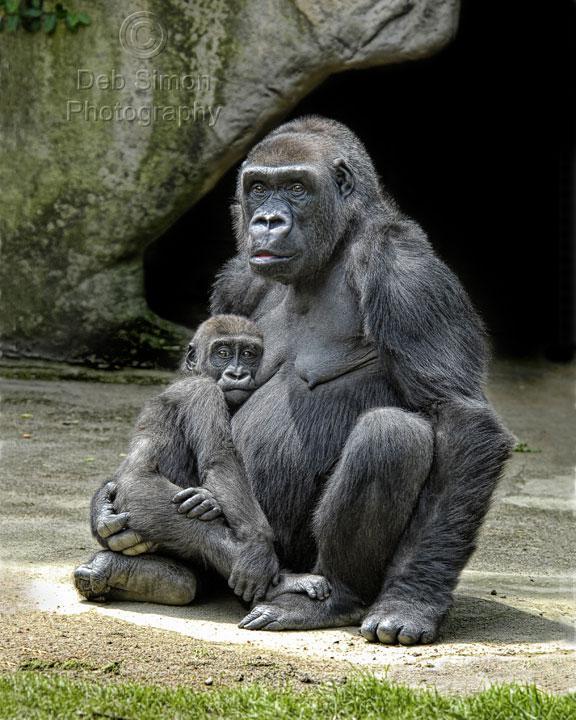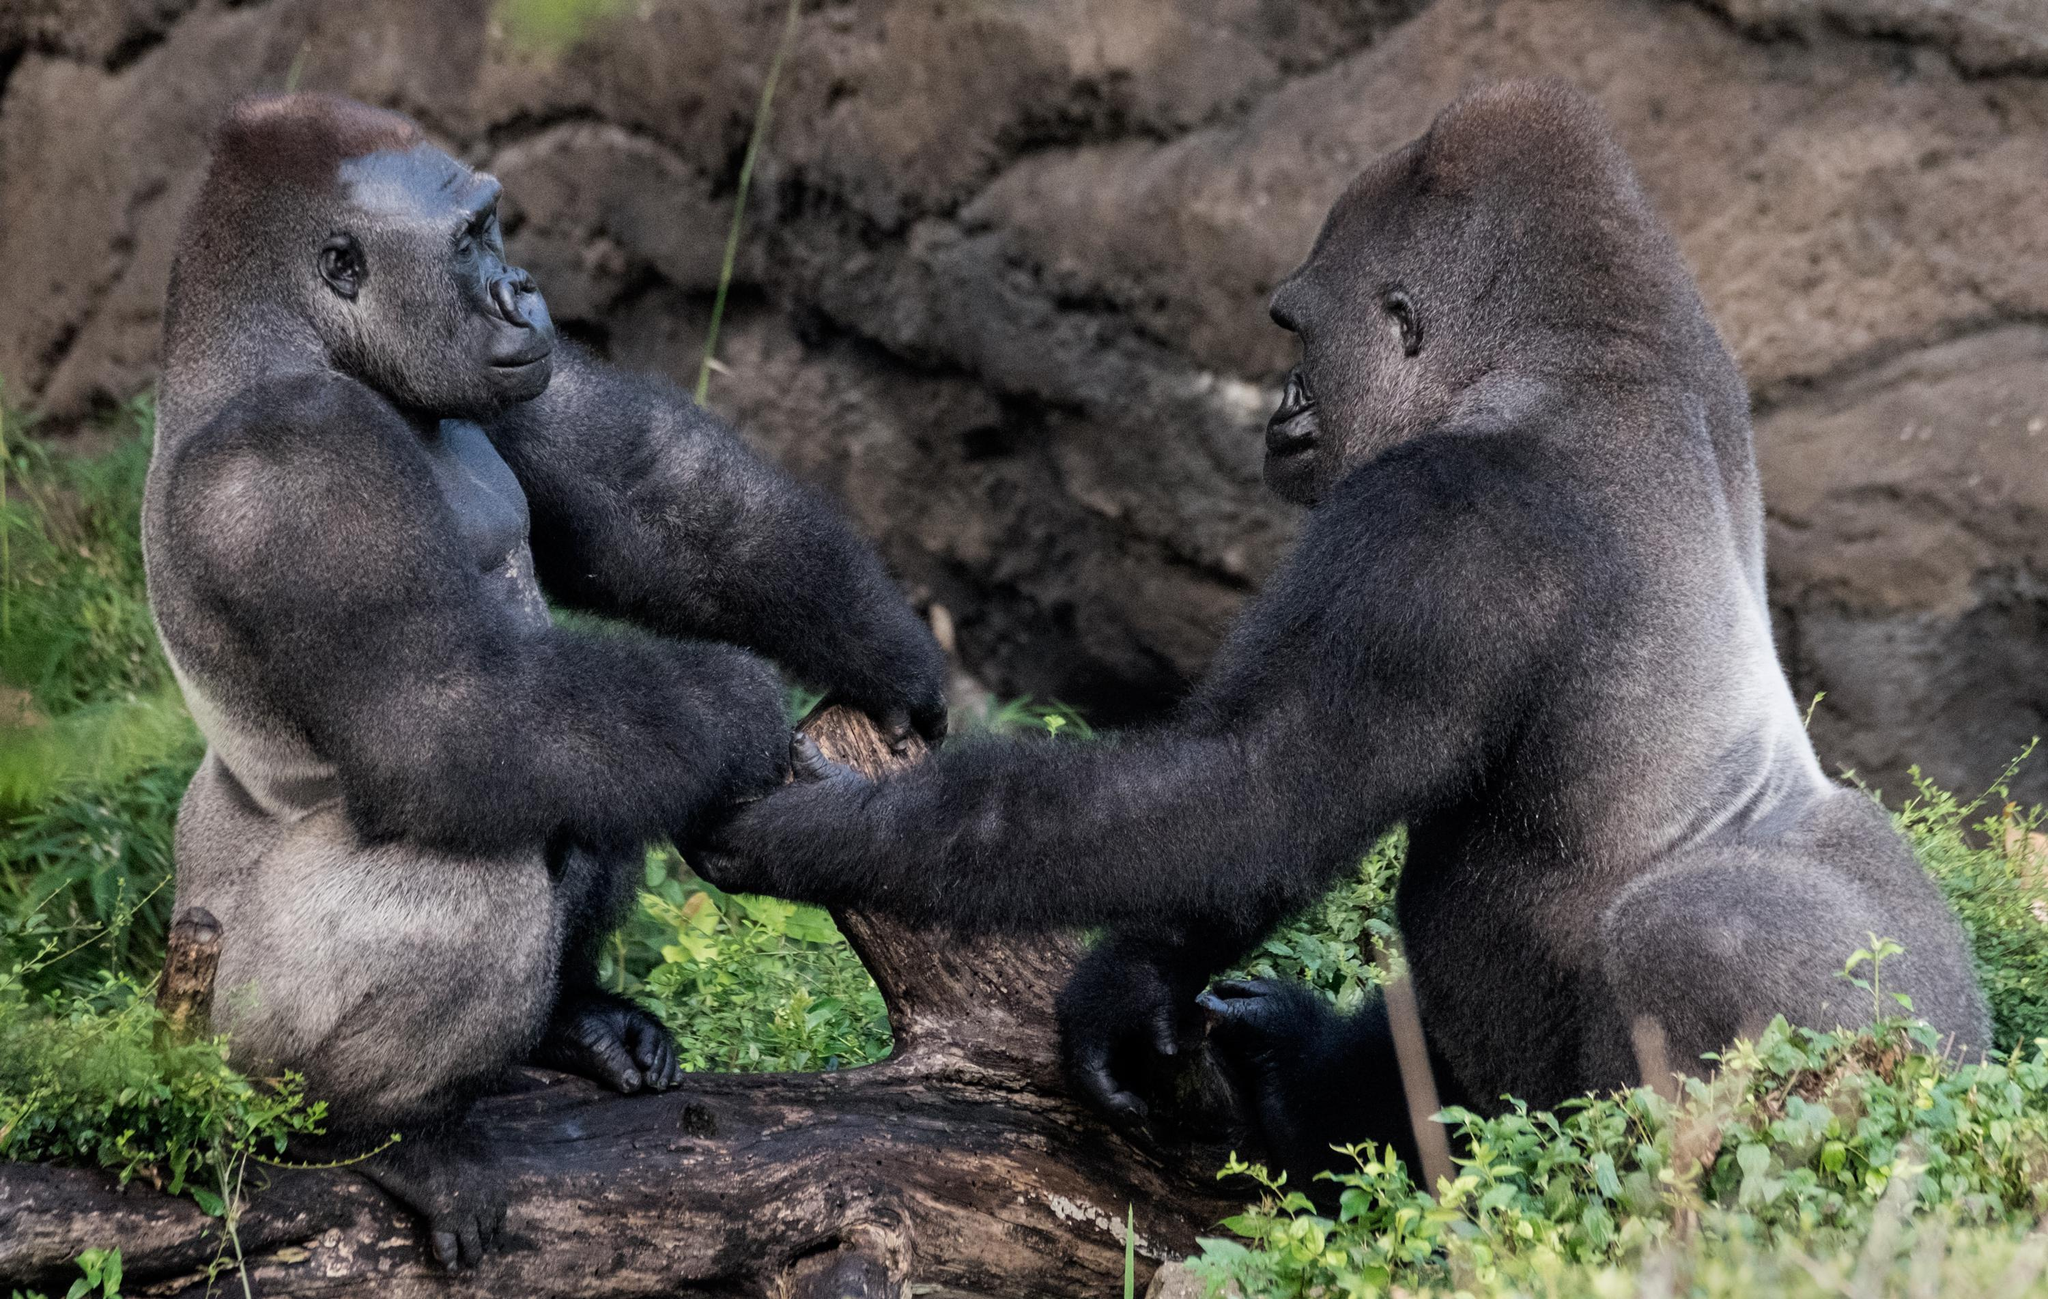The first image is the image on the left, the second image is the image on the right. Assess this claim about the two images: "At least one of the photos contains three or more apes.". Correct or not? Answer yes or no. No. The first image is the image on the left, the second image is the image on the right. Given the left and right images, does the statement "The left image depicts only one adult ape, which has an arm around a younger ape." hold true? Answer yes or no. Yes. 